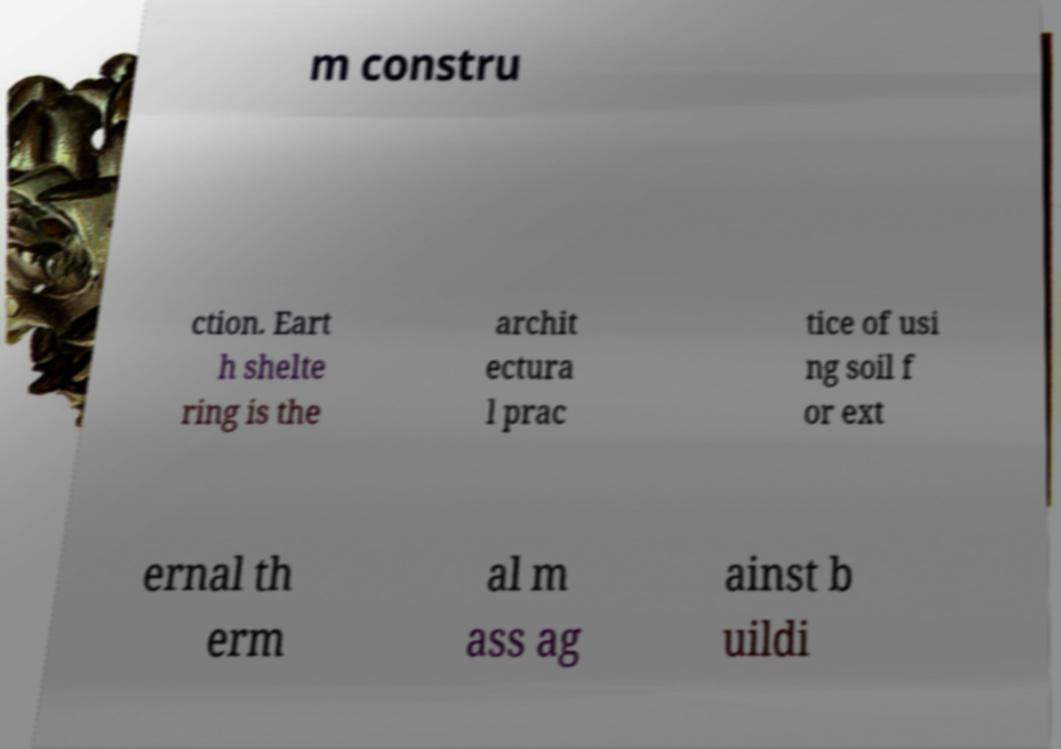Please read and relay the text visible in this image. What does it say? m constru ction. Eart h shelte ring is the archit ectura l prac tice of usi ng soil f or ext ernal th erm al m ass ag ainst b uildi 